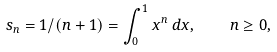<formula> <loc_0><loc_0><loc_500><loc_500>s _ { n } = 1 / ( n + 1 ) = \int _ { 0 } ^ { 1 } x ^ { n } \, d x , \quad n \geq 0 ,</formula> 